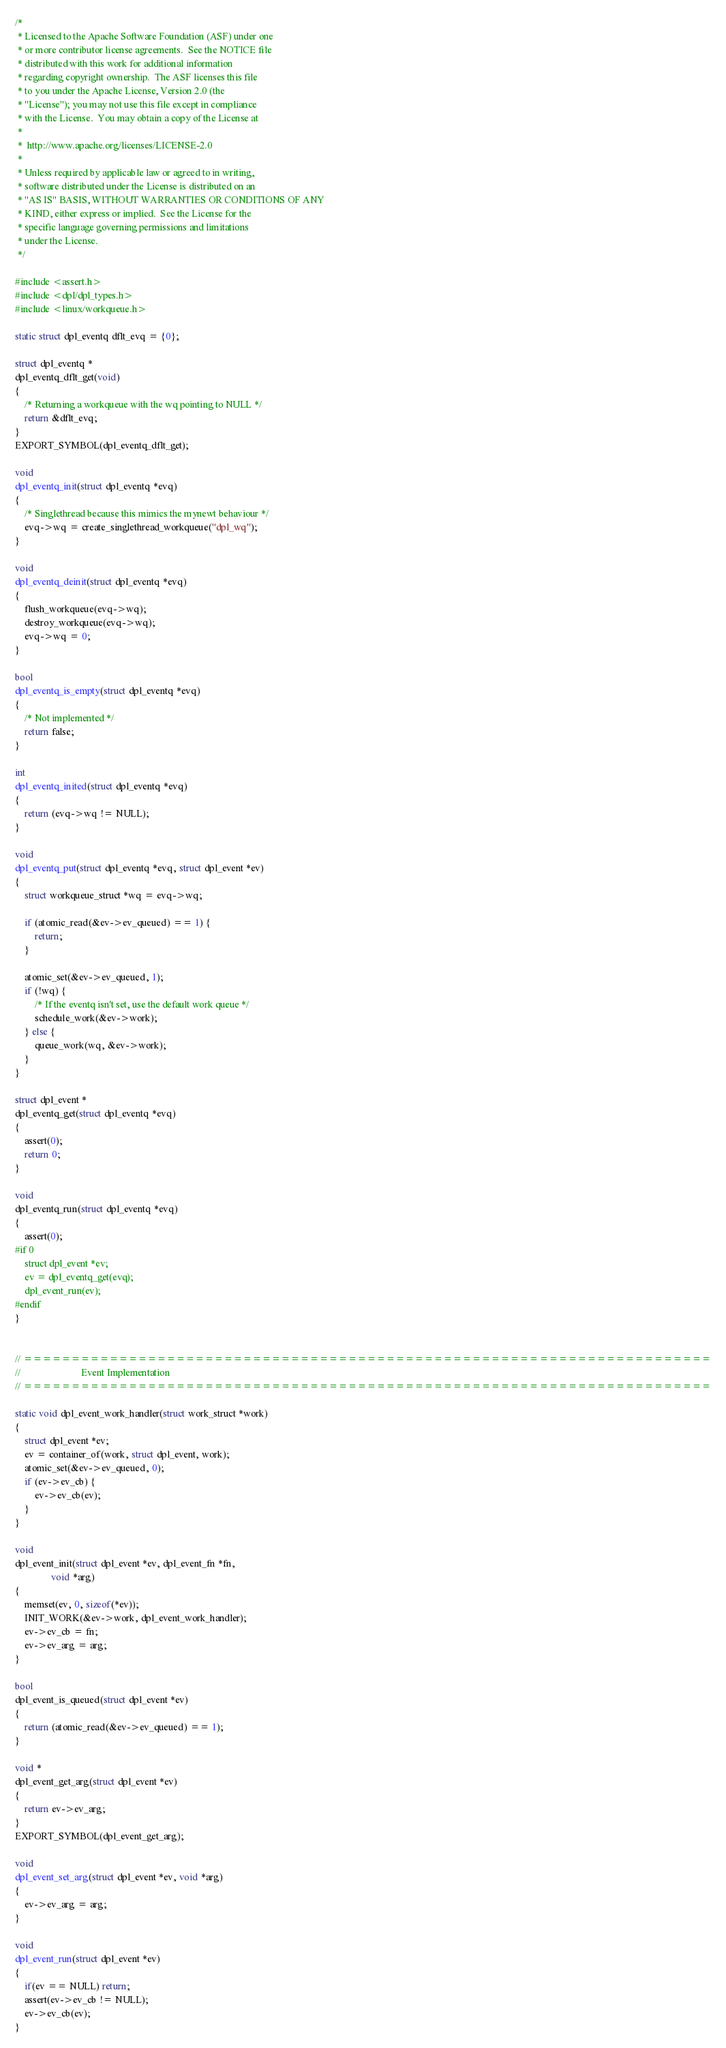<code> <loc_0><loc_0><loc_500><loc_500><_C_>/*
 * Licensed to the Apache Software Foundation (ASF) under one
 * or more contributor license agreements.  See the NOTICE file
 * distributed with this work for additional information
 * regarding copyright ownership.  The ASF licenses this file
 * to you under the Apache License, Version 2.0 (the
 * "License"); you may not use this file except in compliance
 * with the License.  You may obtain a copy of the License at
 *
 *  http://www.apache.org/licenses/LICENSE-2.0
 *
 * Unless required by applicable law or agreed to in writing,
 * software distributed under the License is distributed on an
 * "AS IS" BASIS, WITHOUT WARRANTIES OR CONDITIONS OF ANY
 * KIND, either express or implied.  See the License for the
 * specific language governing permissions and limitations
 * under the License.
 */

#include <assert.h>
#include <dpl/dpl_types.h>
#include <linux/workqueue.h>

static struct dpl_eventq dflt_evq = {0};

struct dpl_eventq *
dpl_eventq_dflt_get(void)
{
    /* Returning a workqueue with the wq pointing to NULL */
    return &dflt_evq;
}
EXPORT_SYMBOL(dpl_eventq_dflt_get);

void
dpl_eventq_init(struct dpl_eventq *evq)
{
    /* Singlethread because this mimics the mynewt behaviour */
    evq->wq = create_singlethread_workqueue("dpl_wq");
}

void
dpl_eventq_deinit(struct dpl_eventq *evq)
{
    flush_workqueue(evq->wq);
    destroy_workqueue(evq->wq);
    evq->wq = 0;
}

bool
dpl_eventq_is_empty(struct dpl_eventq *evq)
{
    /* Not implemented */
    return false;
}

int
dpl_eventq_inited(struct dpl_eventq *evq)
{
    return (evq->wq != NULL);
}

void
dpl_eventq_put(struct dpl_eventq *evq, struct dpl_event *ev)
{
    struct workqueue_struct *wq = evq->wq;

    if (atomic_read(&ev->ev_queued) == 1) {
        return;
    }

    atomic_set(&ev->ev_queued, 1);
    if (!wq) {
        /* If the eventq isn't set, use the default work queue */
        schedule_work(&ev->work);
    } else {
        queue_work(wq, &ev->work);
    }
}

struct dpl_event *
dpl_eventq_get(struct dpl_eventq *evq)
{
    assert(0);
    return 0;
}

void
dpl_eventq_run(struct dpl_eventq *evq)
{
    assert(0);
#if 0
    struct dpl_event *ev;
    ev = dpl_eventq_get(evq);
    dpl_event_run(ev);
#endif
}


// ========================================================================
//                         Event Implementation
// ========================================================================

static void dpl_event_work_handler(struct work_struct *work)
{
    struct dpl_event *ev;
    ev = container_of(work, struct dpl_event, work);
    atomic_set(&ev->ev_queued, 0);
    if (ev->ev_cb) {
        ev->ev_cb(ev);
    }
}

void
dpl_event_init(struct dpl_event *ev, dpl_event_fn *fn,
               void *arg)
{
    memset(ev, 0, sizeof(*ev));
    INIT_WORK(&ev->work, dpl_event_work_handler);
    ev->ev_cb = fn;
    ev->ev_arg = arg;
}

bool
dpl_event_is_queued(struct dpl_event *ev)
{
    return (atomic_read(&ev->ev_queued) == 1);
}

void *
dpl_event_get_arg(struct dpl_event *ev)
{
    return ev->ev_arg;
}
EXPORT_SYMBOL(dpl_event_get_arg);

void
dpl_event_set_arg(struct dpl_event *ev, void *arg)
{
    ev->ev_arg = arg;
}

void
dpl_event_run(struct dpl_event *ev)
{
    if(ev == NULL) return;
    assert(ev->ev_cb != NULL);
    ev->ev_cb(ev);
}
</code> 